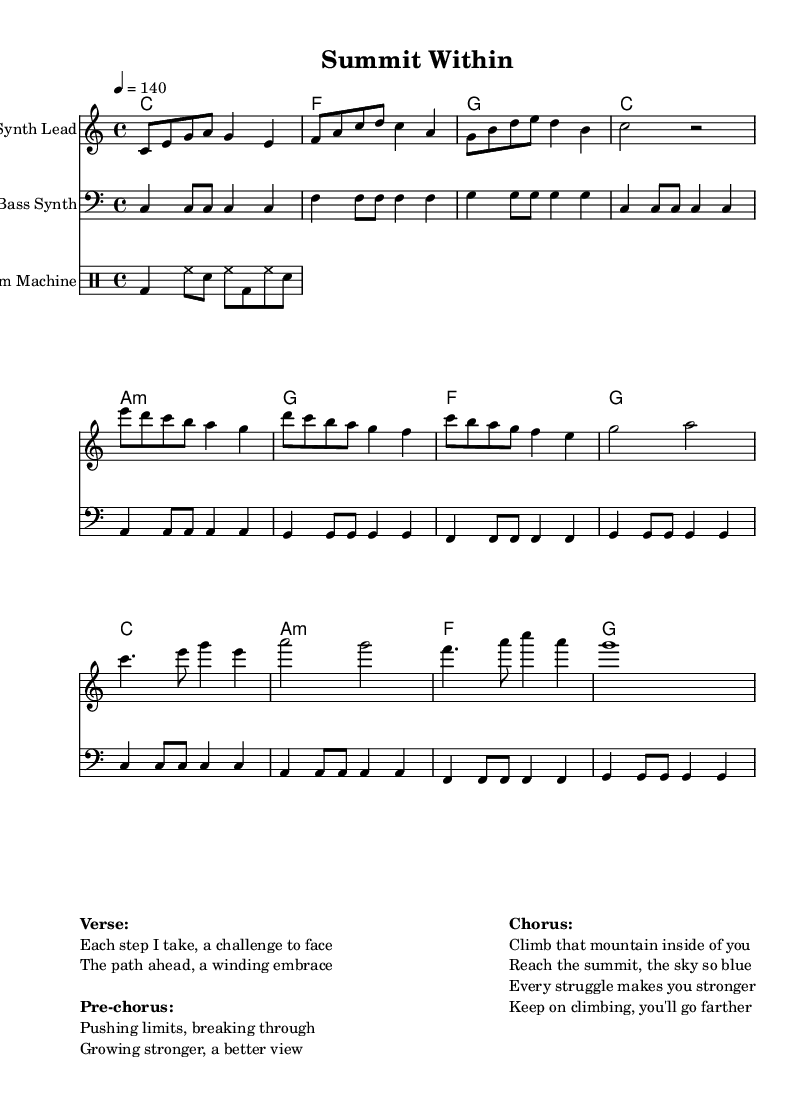What is the key signature of this music? The key signature is C major, which has no sharps or flats.
Answer: C major What is the time signature of this piece? The time signature, indicated at the beginning of the score, is 4/4, meaning there are four beats in each measure.
Answer: 4/4 What is the tempo marking for this piece? The tempo marking states "4 = 140", which indicates that there are 140 beats per minute.
Answer: 140 How many measures are in the verse section? By counting the measures in the verse part of the score, we can see there are four measures listed.
Answer: 4 What instrument plays the main melody? The main melody is performed by the "Synth Lead", as indicated on the staff name.
Answer: Synth Lead How does the chorus differ from the verse in terms of harmony? The chorus features a change in chord progression, specifically using C, A minor, F, and G compared to the verse which uses C, F, G, and C.
Answer: Different chord progression What notable lyrical theme is reflected in the lyrics of this electronic piece? The lyrics focus on personal growth and overcoming challenges, which aligns with the themes typical of high-tempo electronic music.
Answer: Personal growth challenges 